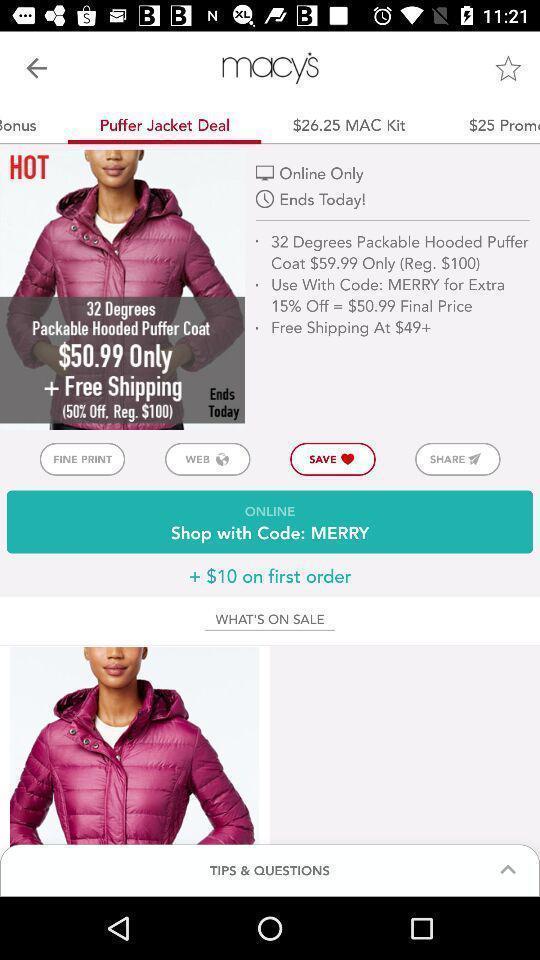Tell me what you see in this picture. Screen shows multiple options in shopping app. 